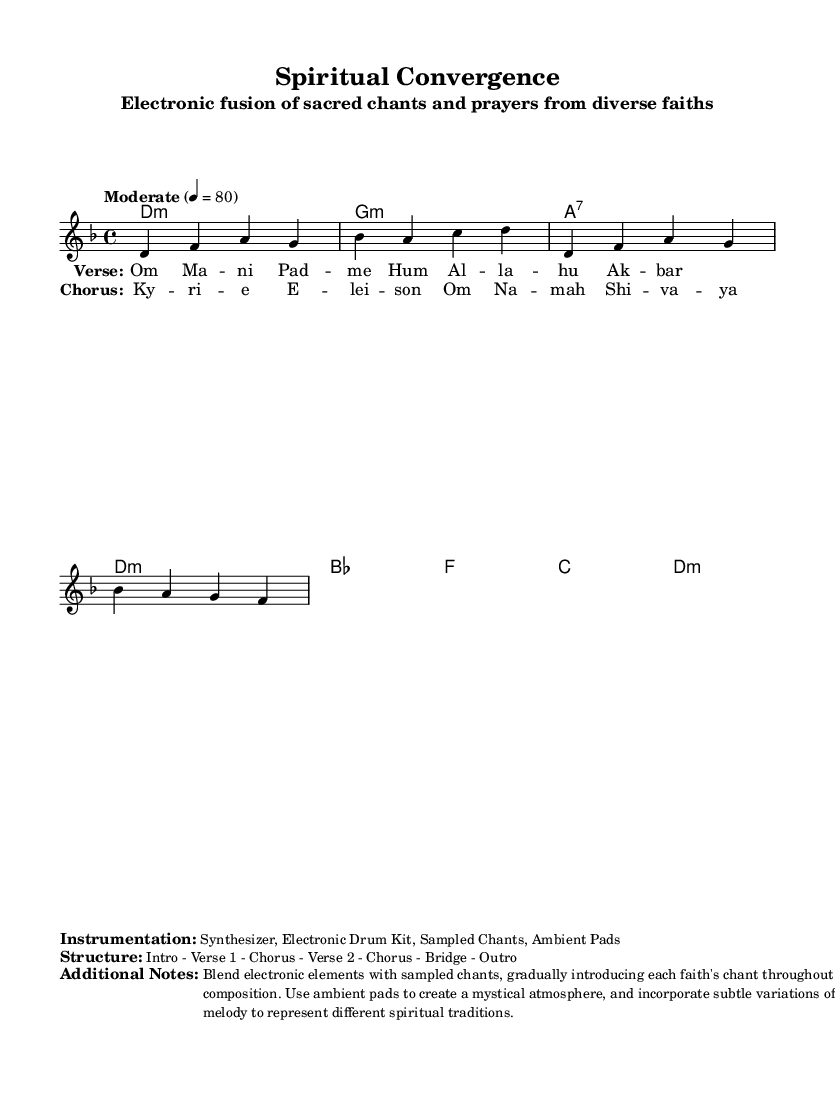What is the key signature of this music? The key signature is indicated at the beginning of the score, which shows a D minor key. D minor has one flat, represented visually in the key signature.
Answer: D minor What is the time signature of this music? The time signature appears after the key signature in the score. Here, it is indicated as 4/4, meaning there are four beats in each measure and a quarter note gets one beat.
Answer: 4/4 What is the tempo marking of this piece? The tempo marking is found near the beginning of the score, showing "Moderate" with a specific metronome marking of 80 beats per minute, indicating the pace of the music.
Answer: Moderate How many verses are present in the structure? The structure is detailed in the markings, which includes mentions of "Verse 1" and "Verse 2", indicating there are two verses in the composition.
Answer: 2 What types of instruments are used in this composition? The instrumentation is specified in the marked section under "Instrumentation" where it lists "Synthesizer, Electronic Drum Kit, Sampled Chants, Ambient Pads" as the instruments used.
Answer: Synthesizer, Electronic Drum Kit, Sampled Chants, Ambient Pads What themes do the lyrics incorporate? The lyrics encompass sacred phrases such as "Om Ma -- ni Pad -- me Hum" from Buddhism and "Al -- la -- hu Ak -- bar" from Islam, showing diversity in the themes. The incorporation of significant chants from various faiths reflects a blending of traditions.
Answer: Sacred phrases from diverse faiths What is the overall structural sequence of this piece? The structure is explicitly outlined under "Structure", detailing the progression of the music as "Intro - Verse 1 - Chorus - Verse 2 - Chorus - Bridge - Outro", which indicates how the composition is organized.
Answer: Intro - Verse 1 - Chorus - Verse 2 - Chorus - Bridge - Outro 